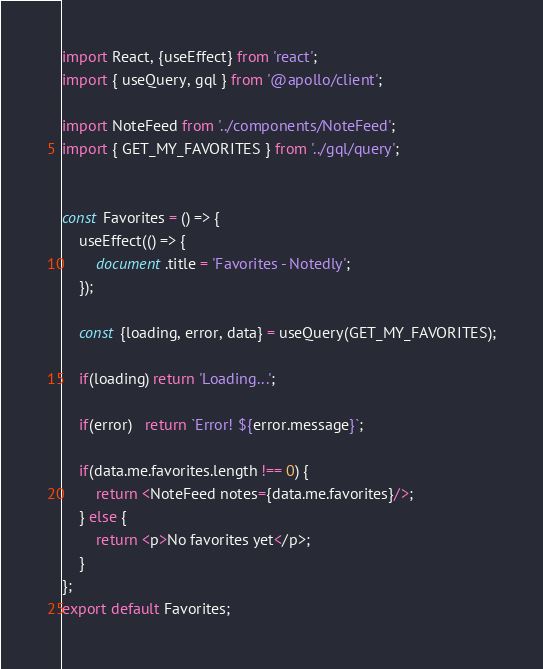<code> <loc_0><loc_0><loc_500><loc_500><_JavaScript_>import React, {useEffect} from 'react';
import { useQuery, gql } from '@apollo/client';

import NoteFeed from '../components/NoteFeed';
import { GET_MY_FAVORITES } from '../gql/query';


const Favorites = () => {
    useEffect(() => {
        document.title = 'Favorites - Notedly';
    });

    const {loading, error, data} = useQuery(GET_MY_FAVORITES);

    if(loading) return 'Loading...';

    if(error)   return `Error! ${error.message}`;

    if(data.me.favorites.length !== 0) {
        return <NoteFeed notes={data.me.favorites}/>;
    } else {
        return <p>No favorites yet</p>;
    }
};
export default Favorites;</code> 